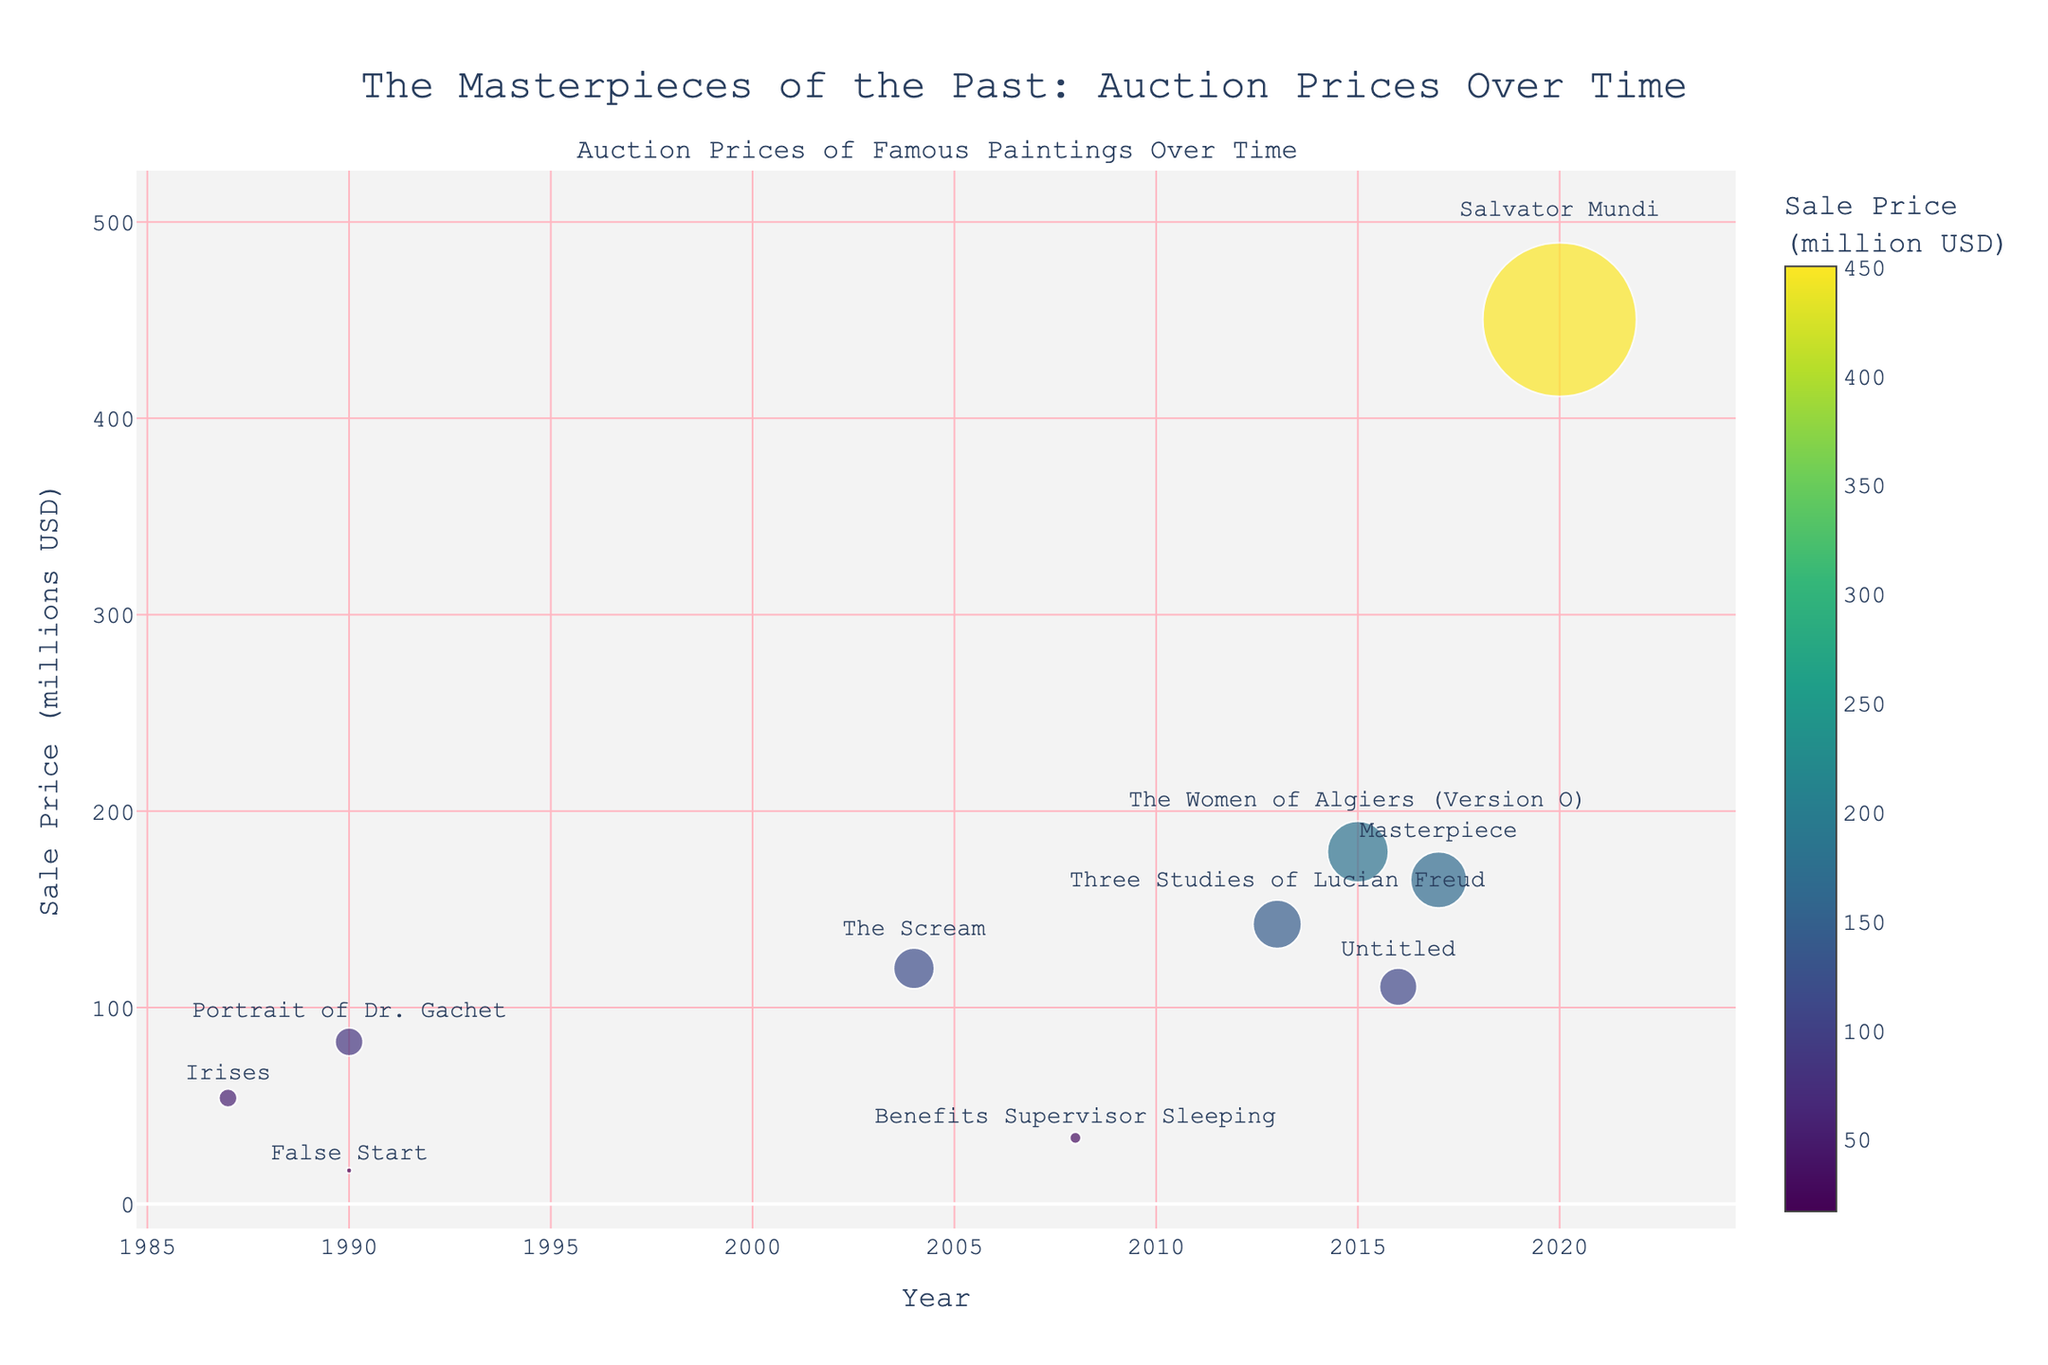What is the title of the figure? The title is always prominently displayed at the top of the plot. Looking at the figure, the title says: "The Masterpieces of the Past: Auction Prices Over Time".
Answer: The Masterpieces of the Past: Auction Prices Over Time Which painting had the highest auction price? The scatter plot markers show the relative sale prices. The painting with the largest marker size and highest y-value reached $450.3 million. According to the hover information, this painting is "Salvator Mundi" by Leonardo da Vinci.
Answer: Salvator Mundi How many paintings from the figure were sold after the year 2000? To determine this, count the number of data points plotted after the year 2000 on the x-axis. Those paintings are "The Women of Algiers (Version O)", "Untitled", "The Scream", "Three Studies of Lucian Freud", "Salvator Mundi", "Masterpiece", and "Benefits Supervisor Sleeping".
Answer: 7 Which painting in the figure was sold at the highest price from the Post-Impressionism period? Identify the data points representing the Post-Impressionism period and compare their sale prices. The data points label paintings "Irises" and "Portrait of Dr. Gachet", with sale prices $53.9 million and $82.5 million respectively. "Portrait of Dr. Gachet" has the highest price.
Answer: Portrait of Dr. Gachet What is the total sale price of all paintings shown in the figure? Sum up the sale prices of all paintings: $53.9 million (Irises) + $82.5 million (Portrait of Dr. Gachet) + $179.3 million (The Women of Algiers) + $110.5 million (Untitled) + $119.9 million (The Scream) + $142.4 million (Three Studies of Lucian Freud) + $450.3 million (Salvator Mundi) + $165.0 million (Masterpiece) + $17.0 million (False Start) + $33.6 million (Benefits Supervisor Sleeping).
Answer: \$1,354.4 million Which art period has the highest average sale price? Group the paintings by their art periods and calculate the average sale price for each group. Post-Impressionism (total: $136.4m, 2 paintings), Cubism (total: $179.3m, 1 painting), Contemporary Art (total: $144.1m, 2 paintings), Symbolism (total: $119.9m, 1 painting), Expressionism (total: $142.4m, 1 painting), High Renaissance (total: $450.3m, 1 painting), Pop Art (total: $165.0m, 1 painting), Abstract Expressionism (total: $17.0m, 1 painting). The High Renaissance has the highest average price of $450.3 million.
Answer: High Renaissance What was the most expensive painting sold before 2000? Examine the auction years to find all paintings sold before 2000, then compare their sale prices. The highest priced painting from this time is "Portrait of Dr. Gachet" with $82.5 million.
Answer: Portrait of Dr. Gachet Which painting by a Contemporary Art artist had the highest sale price? Locate the data points for paintings by Contemporary Art artists. Compare their sale prices. "Untitled" by Jean-Michel Basquiat sold for $110.5 million, which is the highest among them.
Answer: Untitled 